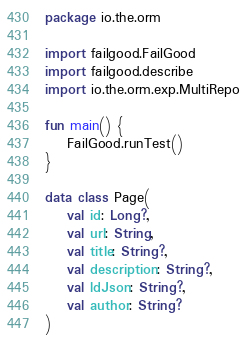Convert code to text. <code><loc_0><loc_0><loc_500><loc_500><_Kotlin_>package io.the.orm

import failgood.FailGood
import failgood.describe
import io.the.orm.exp.MultiRepo

fun main() {
    FailGood.runTest()
}

data class Page(
    val id: Long?,
    val url: String,
    val title: String?,
    val description: String?,
    val ldJson: String?,
    val author: String?
)
</code> 